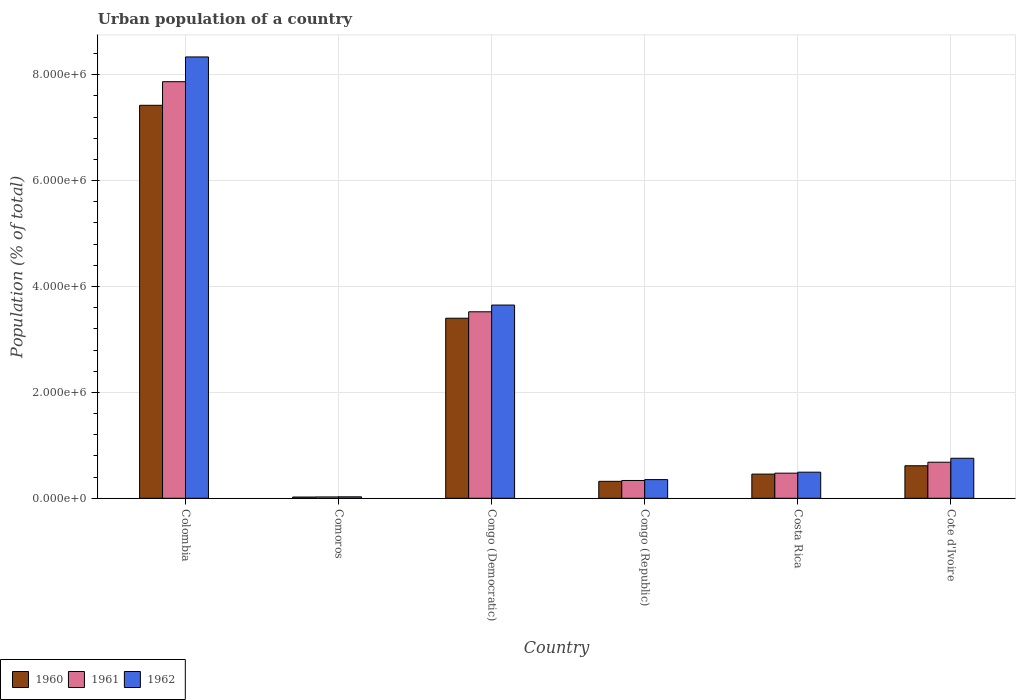How many different coloured bars are there?
Give a very brief answer. 3. Are the number of bars per tick equal to the number of legend labels?
Provide a short and direct response. Yes. Are the number of bars on each tick of the X-axis equal?
Provide a succinct answer. Yes. How many bars are there on the 4th tick from the right?
Your answer should be very brief. 3. What is the label of the 6th group of bars from the left?
Ensure brevity in your answer.  Cote d'Ivoire. What is the urban population in 1961 in Comoros?
Your answer should be compact. 2.56e+04. Across all countries, what is the maximum urban population in 1961?
Offer a terse response. 7.87e+06. Across all countries, what is the minimum urban population in 1961?
Offer a terse response. 2.56e+04. In which country was the urban population in 1960 minimum?
Give a very brief answer. Comoros. What is the total urban population in 1962 in the graph?
Provide a succinct answer. 1.36e+07. What is the difference between the urban population in 1961 in Colombia and that in Cote d'Ivoire?
Provide a succinct answer. 7.19e+06. What is the difference between the urban population in 1962 in Costa Rica and the urban population in 1960 in Congo (Republic)?
Provide a short and direct response. 1.73e+05. What is the average urban population in 1960 per country?
Offer a very short reply. 2.04e+06. What is the difference between the urban population of/in 1960 and urban population of/in 1962 in Congo (Republic)?
Make the answer very short. -3.25e+04. What is the ratio of the urban population in 1961 in Colombia to that in Congo (Republic)?
Ensure brevity in your answer.  23.41. Is the urban population in 1961 in Colombia less than that in Comoros?
Your answer should be very brief. No. Is the difference between the urban population in 1960 in Colombia and Congo (Democratic) greater than the difference between the urban population in 1962 in Colombia and Congo (Democratic)?
Ensure brevity in your answer.  No. What is the difference between the highest and the second highest urban population in 1962?
Provide a short and direct response. 7.58e+06. What is the difference between the highest and the lowest urban population in 1961?
Ensure brevity in your answer.  7.84e+06. Is the sum of the urban population in 1962 in Colombia and Comoros greater than the maximum urban population in 1960 across all countries?
Give a very brief answer. Yes. What does the 3rd bar from the left in Congo (Democratic) represents?
Your answer should be compact. 1962. Is it the case that in every country, the sum of the urban population in 1960 and urban population in 1961 is greater than the urban population in 1962?
Ensure brevity in your answer.  Yes. How many countries are there in the graph?
Provide a short and direct response. 6. Does the graph contain grids?
Give a very brief answer. Yes. What is the title of the graph?
Your response must be concise. Urban population of a country. Does "2002" appear as one of the legend labels in the graph?
Offer a terse response. No. What is the label or title of the X-axis?
Your answer should be compact. Country. What is the label or title of the Y-axis?
Your response must be concise. Population (% of total). What is the Population (% of total) in 1960 in Colombia?
Your answer should be very brief. 7.42e+06. What is the Population (% of total) in 1961 in Colombia?
Keep it short and to the point. 7.87e+06. What is the Population (% of total) of 1962 in Colombia?
Your response must be concise. 8.33e+06. What is the Population (% of total) in 1960 in Comoros?
Offer a very short reply. 2.37e+04. What is the Population (% of total) of 1961 in Comoros?
Keep it short and to the point. 2.56e+04. What is the Population (% of total) of 1962 in Comoros?
Ensure brevity in your answer.  2.77e+04. What is the Population (% of total) of 1960 in Congo (Democratic)?
Ensure brevity in your answer.  3.40e+06. What is the Population (% of total) of 1961 in Congo (Democratic)?
Give a very brief answer. 3.52e+06. What is the Population (% of total) of 1962 in Congo (Democratic)?
Your answer should be compact. 3.65e+06. What is the Population (% of total) in 1960 in Congo (Republic)?
Make the answer very short. 3.20e+05. What is the Population (% of total) in 1961 in Congo (Republic)?
Provide a succinct answer. 3.36e+05. What is the Population (% of total) in 1962 in Congo (Republic)?
Your answer should be compact. 3.53e+05. What is the Population (% of total) of 1960 in Costa Rica?
Your response must be concise. 4.57e+05. What is the Population (% of total) in 1961 in Costa Rica?
Offer a very short reply. 4.74e+05. What is the Population (% of total) of 1962 in Costa Rica?
Give a very brief answer. 4.93e+05. What is the Population (% of total) of 1960 in Cote d'Ivoire?
Provide a short and direct response. 6.14e+05. What is the Population (% of total) in 1961 in Cote d'Ivoire?
Offer a terse response. 6.81e+05. What is the Population (% of total) in 1962 in Cote d'Ivoire?
Offer a terse response. 7.56e+05. Across all countries, what is the maximum Population (% of total) in 1960?
Provide a short and direct response. 7.42e+06. Across all countries, what is the maximum Population (% of total) in 1961?
Your answer should be very brief. 7.87e+06. Across all countries, what is the maximum Population (% of total) of 1962?
Your answer should be compact. 8.33e+06. Across all countries, what is the minimum Population (% of total) in 1960?
Provide a short and direct response. 2.37e+04. Across all countries, what is the minimum Population (% of total) in 1961?
Provide a short and direct response. 2.56e+04. Across all countries, what is the minimum Population (% of total) of 1962?
Offer a terse response. 2.77e+04. What is the total Population (% of total) in 1960 in the graph?
Provide a short and direct response. 1.22e+07. What is the total Population (% of total) of 1961 in the graph?
Offer a very short reply. 1.29e+07. What is the total Population (% of total) of 1962 in the graph?
Give a very brief answer. 1.36e+07. What is the difference between the Population (% of total) of 1960 in Colombia and that in Comoros?
Your response must be concise. 7.40e+06. What is the difference between the Population (% of total) of 1961 in Colombia and that in Comoros?
Provide a short and direct response. 7.84e+06. What is the difference between the Population (% of total) in 1962 in Colombia and that in Comoros?
Ensure brevity in your answer.  8.31e+06. What is the difference between the Population (% of total) of 1960 in Colombia and that in Congo (Democratic)?
Your answer should be compact. 4.02e+06. What is the difference between the Population (% of total) of 1961 in Colombia and that in Congo (Democratic)?
Give a very brief answer. 4.35e+06. What is the difference between the Population (% of total) in 1962 in Colombia and that in Congo (Democratic)?
Give a very brief answer. 4.69e+06. What is the difference between the Population (% of total) of 1960 in Colombia and that in Congo (Republic)?
Offer a terse response. 7.10e+06. What is the difference between the Population (% of total) of 1961 in Colombia and that in Congo (Republic)?
Keep it short and to the point. 7.53e+06. What is the difference between the Population (% of total) of 1962 in Colombia and that in Congo (Republic)?
Provide a short and direct response. 7.98e+06. What is the difference between the Population (% of total) of 1960 in Colombia and that in Costa Rica?
Give a very brief answer. 6.96e+06. What is the difference between the Population (% of total) in 1961 in Colombia and that in Costa Rica?
Your answer should be compact. 7.39e+06. What is the difference between the Population (% of total) in 1962 in Colombia and that in Costa Rica?
Offer a very short reply. 7.84e+06. What is the difference between the Population (% of total) in 1960 in Colombia and that in Cote d'Ivoire?
Offer a very short reply. 6.81e+06. What is the difference between the Population (% of total) in 1961 in Colombia and that in Cote d'Ivoire?
Provide a short and direct response. 7.19e+06. What is the difference between the Population (% of total) of 1962 in Colombia and that in Cote d'Ivoire?
Your answer should be very brief. 7.58e+06. What is the difference between the Population (% of total) of 1960 in Comoros and that in Congo (Democratic)?
Your response must be concise. -3.38e+06. What is the difference between the Population (% of total) in 1961 in Comoros and that in Congo (Democratic)?
Give a very brief answer. -3.50e+06. What is the difference between the Population (% of total) in 1962 in Comoros and that in Congo (Democratic)?
Offer a very short reply. -3.62e+06. What is the difference between the Population (% of total) of 1960 in Comoros and that in Congo (Republic)?
Provide a succinct answer. -2.97e+05. What is the difference between the Population (% of total) in 1961 in Comoros and that in Congo (Republic)?
Your response must be concise. -3.10e+05. What is the difference between the Population (% of total) in 1962 in Comoros and that in Congo (Republic)?
Give a very brief answer. -3.25e+05. What is the difference between the Population (% of total) in 1960 in Comoros and that in Costa Rica?
Ensure brevity in your answer.  -4.33e+05. What is the difference between the Population (% of total) of 1961 in Comoros and that in Costa Rica?
Your answer should be compact. -4.49e+05. What is the difference between the Population (% of total) in 1962 in Comoros and that in Costa Rica?
Your answer should be compact. -4.65e+05. What is the difference between the Population (% of total) of 1960 in Comoros and that in Cote d'Ivoire?
Keep it short and to the point. -5.91e+05. What is the difference between the Population (% of total) of 1961 in Comoros and that in Cote d'Ivoire?
Your response must be concise. -6.56e+05. What is the difference between the Population (% of total) in 1962 in Comoros and that in Cote d'Ivoire?
Your response must be concise. -7.28e+05. What is the difference between the Population (% of total) in 1960 in Congo (Democratic) and that in Congo (Republic)?
Provide a succinct answer. 3.08e+06. What is the difference between the Population (% of total) in 1961 in Congo (Democratic) and that in Congo (Republic)?
Give a very brief answer. 3.19e+06. What is the difference between the Population (% of total) in 1962 in Congo (Democratic) and that in Congo (Republic)?
Offer a terse response. 3.30e+06. What is the difference between the Population (% of total) in 1960 in Congo (Democratic) and that in Costa Rica?
Offer a very short reply. 2.94e+06. What is the difference between the Population (% of total) in 1961 in Congo (Democratic) and that in Costa Rica?
Provide a short and direct response. 3.05e+06. What is the difference between the Population (% of total) in 1962 in Congo (Democratic) and that in Costa Rica?
Provide a succinct answer. 3.16e+06. What is the difference between the Population (% of total) of 1960 in Congo (Democratic) and that in Cote d'Ivoire?
Your answer should be very brief. 2.79e+06. What is the difference between the Population (% of total) of 1961 in Congo (Democratic) and that in Cote d'Ivoire?
Make the answer very short. 2.84e+06. What is the difference between the Population (% of total) of 1962 in Congo (Democratic) and that in Cote d'Ivoire?
Keep it short and to the point. 2.89e+06. What is the difference between the Population (% of total) of 1960 in Congo (Republic) and that in Costa Rica?
Ensure brevity in your answer.  -1.36e+05. What is the difference between the Population (% of total) of 1961 in Congo (Republic) and that in Costa Rica?
Keep it short and to the point. -1.38e+05. What is the difference between the Population (% of total) of 1962 in Congo (Republic) and that in Costa Rica?
Offer a very short reply. -1.40e+05. What is the difference between the Population (% of total) of 1960 in Congo (Republic) and that in Cote d'Ivoire?
Ensure brevity in your answer.  -2.94e+05. What is the difference between the Population (% of total) in 1961 in Congo (Republic) and that in Cote d'Ivoire?
Offer a very short reply. -3.45e+05. What is the difference between the Population (% of total) of 1962 in Congo (Republic) and that in Cote d'Ivoire?
Ensure brevity in your answer.  -4.03e+05. What is the difference between the Population (% of total) in 1960 in Costa Rica and that in Cote d'Ivoire?
Provide a short and direct response. -1.58e+05. What is the difference between the Population (% of total) of 1961 in Costa Rica and that in Cote d'Ivoire?
Your answer should be compact. -2.07e+05. What is the difference between the Population (% of total) of 1962 in Costa Rica and that in Cote d'Ivoire?
Provide a short and direct response. -2.63e+05. What is the difference between the Population (% of total) in 1960 in Colombia and the Population (% of total) in 1961 in Comoros?
Make the answer very short. 7.40e+06. What is the difference between the Population (% of total) in 1960 in Colombia and the Population (% of total) in 1962 in Comoros?
Offer a very short reply. 7.39e+06. What is the difference between the Population (% of total) of 1961 in Colombia and the Population (% of total) of 1962 in Comoros?
Ensure brevity in your answer.  7.84e+06. What is the difference between the Population (% of total) of 1960 in Colombia and the Population (% of total) of 1961 in Congo (Democratic)?
Give a very brief answer. 3.90e+06. What is the difference between the Population (% of total) in 1960 in Colombia and the Population (% of total) in 1962 in Congo (Democratic)?
Give a very brief answer. 3.77e+06. What is the difference between the Population (% of total) in 1961 in Colombia and the Population (% of total) in 1962 in Congo (Democratic)?
Provide a short and direct response. 4.22e+06. What is the difference between the Population (% of total) in 1960 in Colombia and the Population (% of total) in 1961 in Congo (Republic)?
Your answer should be compact. 7.09e+06. What is the difference between the Population (% of total) in 1960 in Colombia and the Population (% of total) in 1962 in Congo (Republic)?
Your answer should be compact. 7.07e+06. What is the difference between the Population (% of total) of 1961 in Colombia and the Population (% of total) of 1962 in Congo (Republic)?
Provide a short and direct response. 7.51e+06. What is the difference between the Population (% of total) of 1960 in Colombia and the Population (% of total) of 1961 in Costa Rica?
Your answer should be very brief. 6.95e+06. What is the difference between the Population (% of total) of 1960 in Colombia and the Population (% of total) of 1962 in Costa Rica?
Give a very brief answer. 6.93e+06. What is the difference between the Population (% of total) in 1961 in Colombia and the Population (% of total) in 1962 in Costa Rica?
Make the answer very short. 7.37e+06. What is the difference between the Population (% of total) of 1960 in Colombia and the Population (% of total) of 1961 in Cote d'Ivoire?
Your response must be concise. 6.74e+06. What is the difference between the Population (% of total) of 1960 in Colombia and the Population (% of total) of 1962 in Cote d'Ivoire?
Ensure brevity in your answer.  6.67e+06. What is the difference between the Population (% of total) of 1961 in Colombia and the Population (% of total) of 1962 in Cote d'Ivoire?
Your answer should be very brief. 7.11e+06. What is the difference between the Population (% of total) of 1960 in Comoros and the Population (% of total) of 1961 in Congo (Democratic)?
Ensure brevity in your answer.  -3.50e+06. What is the difference between the Population (% of total) of 1960 in Comoros and the Population (% of total) of 1962 in Congo (Democratic)?
Keep it short and to the point. -3.63e+06. What is the difference between the Population (% of total) of 1961 in Comoros and the Population (% of total) of 1962 in Congo (Democratic)?
Keep it short and to the point. -3.62e+06. What is the difference between the Population (% of total) in 1960 in Comoros and the Population (% of total) in 1961 in Congo (Republic)?
Provide a short and direct response. -3.12e+05. What is the difference between the Population (% of total) of 1960 in Comoros and the Population (% of total) of 1962 in Congo (Republic)?
Make the answer very short. -3.29e+05. What is the difference between the Population (% of total) of 1961 in Comoros and the Population (% of total) of 1962 in Congo (Republic)?
Provide a succinct answer. -3.27e+05. What is the difference between the Population (% of total) of 1960 in Comoros and the Population (% of total) of 1961 in Costa Rica?
Your answer should be compact. -4.51e+05. What is the difference between the Population (% of total) of 1960 in Comoros and the Population (% of total) of 1962 in Costa Rica?
Give a very brief answer. -4.69e+05. What is the difference between the Population (% of total) of 1961 in Comoros and the Population (% of total) of 1962 in Costa Rica?
Keep it short and to the point. -4.67e+05. What is the difference between the Population (% of total) of 1960 in Comoros and the Population (% of total) of 1961 in Cote d'Ivoire?
Offer a terse response. -6.58e+05. What is the difference between the Population (% of total) of 1960 in Comoros and the Population (% of total) of 1962 in Cote d'Ivoire?
Make the answer very short. -7.32e+05. What is the difference between the Population (% of total) in 1961 in Comoros and the Population (% of total) in 1962 in Cote d'Ivoire?
Provide a short and direct response. -7.30e+05. What is the difference between the Population (% of total) of 1960 in Congo (Democratic) and the Population (% of total) of 1961 in Congo (Republic)?
Offer a terse response. 3.06e+06. What is the difference between the Population (% of total) in 1960 in Congo (Democratic) and the Population (% of total) in 1962 in Congo (Republic)?
Your response must be concise. 3.05e+06. What is the difference between the Population (% of total) in 1961 in Congo (Democratic) and the Population (% of total) in 1962 in Congo (Republic)?
Keep it short and to the point. 3.17e+06. What is the difference between the Population (% of total) of 1960 in Congo (Democratic) and the Population (% of total) of 1961 in Costa Rica?
Keep it short and to the point. 2.93e+06. What is the difference between the Population (% of total) of 1960 in Congo (Democratic) and the Population (% of total) of 1962 in Costa Rica?
Offer a terse response. 2.91e+06. What is the difference between the Population (% of total) of 1961 in Congo (Democratic) and the Population (% of total) of 1962 in Costa Rica?
Give a very brief answer. 3.03e+06. What is the difference between the Population (% of total) of 1960 in Congo (Democratic) and the Population (% of total) of 1961 in Cote d'Ivoire?
Offer a terse response. 2.72e+06. What is the difference between the Population (% of total) of 1960 in Congo (Democratic) and the Population (% of total) of 1962 in Cote d'Ivoire?
Give a very brief answer. 2.64e+06. What is the difference between the Population (% of total) in 1961 in Congo (Democratic) and the Population (% of total) in 1962 in Cote d'Ivoire?
Offer a terse response. 2.77e+06. What is the difference between the Population (% of total) of 1960 in Congo (Republic) and the Population (% of total) of 1961 in Costa Rica?
Your answer should be very brief. -1.54e+05. What is the difference between the Population (% of total) in 1960 in Congo (Republic) and the Population (% of total) in 1962 in Costa Rica?
Ensure brevity in your answer.  -1.73e+05. What is the difference between the Population (% of total) of 1961 in Congo (Republic) and the Population (% of total) of 1962 in Costa Rica?
Your answer should be very brief. -1.57e+05. What is the difference between the Population (% of total) in 1960 in Congo (Republic) and the Population (% of total) in 1961 in Cote d'Ivoire?
Ensure brevity in your answer.  -3.61e+05. What is the difference between the Population (% of total) in 1960 in Congo (Republic) and the Population (% of total) in 1962 in Cote d'Ivoire?
Give a very brief answer. -4.36e+05. What is the difference between the Population (% of total) in 1961 in Congo (Republic) and the Population (% of total) in 1962 in Cote d'Ivoire?
Ensure brevity in your answer.  -4.20e+05. What is the difference between the Population (% of total) of 1960 in Costa Rica and the Population (% of total) of 1961 in Cote d'Ivoire?
Your answer should be very brief. -2.25e+05. What is the difference between the Population (% of total) of 1960 in Costa Rica and the Population (% of total) of 1962 in Cote d'Ivoire?
Your response must be concise. -2.99e+05. What is the difference between the Population (% of total) in 1961 in Costa Rica and the Population (% of total) in 1962 in Cote d'Ivoire?
Provide a short and direct response. -2.82e+05. What is the average Population (% of total) of 1960 per country?
Provide a short and direct response. 2.04e+06. What is the average Population (% of total) of 1961 per country?
Your response must be concise. 2.15e+06. What is the average Population (% of total) of 1962 per country?
Your response must be concise. 2.27e+06. What is the difference between the Population (% of total) of 1960 and Population (% of total) of 1961 in Colombia?
Provide a short and direct response. -4.46e+05. What is the difference between the Population (% of total) of 1960 and Population (% of total) of 1962 in Colombia?
Ensure brevity in your answer.  -9.13e+05. What is the difference between the Population (% of total) in 1961 and Population (% of total) in 1962 in Colombia?
Your response must be concise. -4.68e+05. What is the difference between the Population (% of total) in 1960 and Population (% of total) in 1961 in Comoros?
Give a very brief answer. -1917. What is the difference between the Population (% of total) in 1960 and Population (% of total) in 1962 in Comoros?
Provide a short and direct response. -3975. What is the difference between the Population (% of total) of 1961 and Population (% of total) of 1962 in Comoros?
Your response must be concise. -2058. What is the difference between the Population (% of total) in 1960 and Population (% of total) in 1961 in Congo (Democratic)?
Provide a succinct answer. -1.22e+05. What is the difference between the Population (% of total) in 1960 and Population (% of total) in 1962 in Congo (Democratic)?
Make the answer very short. -2.49e+05. What is the difference between the Population (% of total) in 1961 and Population (% of total) in 1962 in Congo (Democratic)?
Provide a succinct answer. -1.27e+05. What is the difference between the Population (% of total) in 1960 and Population (% of total) in 1961 in Congo (Republic)?
Offer a very short reply. -1.58e+04. What is the difference between the Population (% of total) of 1960 and Population (% of total) of 1962 in Congo (Republic)?
Offer a terse response. -3.25e+04. What is the difference between the Population (% of total) of 1961 and Population (% of total) of 1962 in Congo (Republic)?
Provide a succinct answer. -1.67e+04. What is the difference between the Population (% of total) of 1960 and Population (% of total) of 1961 in Costa Rica?
Keep it short and to the point. -1.78e+04. What is the difference between the Population (% of total) in 1960 and Population (% of total) in 1962 in Costa Rica?
Your answer should be compact. -3.62e+04. What is the difference between the Population (% of total) of 1961 and Population (% of total) of 1962 in Costa Rica?
Your response must be concise. -1.85e+04. What is the difference between the Population (% of total) in 1960 and Population (% of total) in 1961 in Cote d'Ivoire?
Offer a very short reply. -6.69e+04. What is the difference between the Population (% of total) of 1960 and Population (% of total) of 1962 in Cote d'Ivoire?
Your answer should be very brief. -1.42e+05. What is the difference between the Population (% of total) in 1961 and Population (% of total) in 1962 in Cote d'Ivoire?
Offer a terse response. -7.48e+04. What is the ratio of the Population (% of total) of 1960 in Colombia to that in Comoros?
Your answer should be very brief. 313.31. What is the ratio of the Population (% of total) of 1961 in Colombia to that in Comoros?
Give a very brief answer. 307.26. What is the ratio of the Population (% of total) in 1962 in Colombia to that in Comoros?
Provide a succinct answer. 301.3. What is the ratio of the Population (% of total) of 1960 in Colombia to that in Congo (Democratic)?
Offer a very short reply. 2.18. What is the ratio of the Population (% of total) of 1961 in Colombia to that in Congo (Democratic)?
Ensure brevity in your answer.  2.23. What is the ratio of the Population (% of total) of 1962 in Colombia to that in Congo (Democratic)?
Provide a succinct answer. 2.28. What is the ratio of the Population (% of total) in 1960 in Colombia to that in Congo (Republic)?
Keep it short and to the point. 23.17. What is the ratio of the Population (% of total) of 1961 in Colombia to that in Congo (Republic)?
Keep it short and to the point. 23.41. What is the ratio of the Population (% of total) in 1962 in Colombia to that in Congo (Republic)?
Make the answer very short. 23.63. What is the ratio of the Population (% of total) in 1960 in Colombia to that in Costa Rica?
Your answer should be very brief. 16.25. What is the ratio of the Population (% of total) of 1961 in Colombia to that in Costa Rica?
Provide a succinct answer. 16.58. What is the ratio of the Population (% of total) in 1962 in Colombia to that in Costa Rica?
Your answer should be compact. 16.91. What is the ratio of the Population (% of total) in 1960 in Colombia to that in Cote d'Ivoire?
Provide a succinct answer. 12.08. What is the ratio of the Population (% of total) in 1961 in Colombia to that in Cote d'Ivoire?
Offer a terse response. 11.55. What is the ratio of the Population (% of total) in 1962 in Colombia to that in Cote d'Ivoire?
Give a very brief answer. 11.03. What is the ratio of the Population (% of total) in 1960 in Comoros to that in Congo (Democratic)?
Ensure brevity in your answer.  0.01. What is the ratio of the Population (% of total) in 1961 in Comoros to that in Congo (Democratic)?
Your response must be concise. 0.01. What is the ratio of the Population (% of total) of 1962 in Comoros to that in Congo (Democratic)?
Your response must be concise. 0.01. What is the ratio of the Population (% of total) in 1960 in Comoros to that in Congo (Republic)?
Offer a terse response. 0.07. What is the ratio of the Population (% of total) in 1961 in Comoros to that in Congo (Republic)?
Make the answer very short. 0.08. What is the ratio of the Population (% of total) in 1962 in Comoros to that in Congo (Republic)?
Offer a terse response. 0.08. What is the ratio of the Population (% of total) of 1960 in Comoros to that in Costa Rica?
Provide a succinct answer. 0.05. What is the ratio of the Population (% of total) of 1961 in Comoros to that in Costa Rica?
Provide a short and direct response. 0.05. What is the ratio of the Population (% of total) of 1962 in Comoros to that in Costa Rica?
Offer a terse response. 0.06. What is the ratio of the Population (% of total) of 1960 in Comoros to that in Cote d'Ivoire?
Ensure brevity in your answer.  0.04. What is the ratio of the Population (% of total) of 1961 in Comoros to that in Cote d'Ivoire?
Keep it short and to the point. 0.04. What is the ratio of the Population (% of total) in 1962 in Comoros to that in Cote d'Ivoire?
Your answer should be compact. 0.04. What is the ratio of the Population (% of total) in 1960 in Congo (Democratic) to that in Congo (Republic)?
Ensure brevity in your answer.  10.62. What is the ratio of the Population (% of total) in 1961 in Congo (Democratic) to that in Congo (Republic)?
Provide a short and direct response. 10.48. What is the ratio of the Population (% of total) of 1962 in Congo (Democratic) to that in Congo (Republic)?
Your answer should be compact. 10.34. What is the ratio of the Population (% of total) in 1960 in Congo (Democratic) to that in Costa Rica?
Ensure brevity in your answer.  7.45. What is the ratio of the Population (% of total) in 1961 in Congo (Democratic) to that in Costa Rica?
Give a very brief answer. 7.42. What is the ratio of the Population (% of total) of 1962 in Congo (Democratic) to that in Costa Rica?
Your response must be concise. 7.4. What is the ratio of the Population (% of total) of 1960 in Congo (Democratic) to that in Cote d'Ivoire?
Provide a succinct answer. 5.54. What is the ratio of the Population (% of total) in 1961 in Congo (Democratic) to that in Cote d'Ivoire?
Offer a terse response. 5.17. What is the ratio of the Population (% of total) of 1962 in Congo (Democratic) to that in Cote d'Ivoire?
Ensure brevity in your answer.  4.83. What is the ratio of the Population (% of total) in 1960 in Congo (Republic) to that in Costa Rica?
Your answer should be compact. 0.7. What is the ratio of the Population (% of total) in 1961 in Congo (Republic) to that in Costa Rica?
Keep it short and to the point. 0.71. What is the ratio of the Population (% of total) of 1962 in Congo (Republic) to that in Costa Rica?
Your answer should be very brief. 0.72. What is the ratio of the Population (% of total) of 1960 in Congo (Republic) to that in Cote d'Ivoire?
Your answer should be compact. 0.52. What is the ratio of the Population (% of total) of 1961 in Congo (Republic) to that in Cote d'Ivoire?
Offer a terse response. 0.49. What is the ratio of the Population (% of total) of 1962 in Congo (Republic) to that in Cote d'Ivoire?
Provide a succinct answer. 0.47. What is the ratio of the Population (% of total) in 1960 in Costa Rica to that in Cote d'Ivoire?
Provide a succinct answer. 0.74. What is the ratio of the Population (% of total) of 1961 in Costa Rica to that in Cote d'Ivoire?
Provide a succinct answer. 0.7. What is the ratio of the Population (% of total) of 1962 in Costa Rica to that in Cote d'Ivoire?
Ensure brevity in your answer.  0.65. What is the difference between the highest and the second highest Population (% of total) in 1960?
Offer a terse response. 4.02e+06. What is the difference between the highest and the second highest Population (% of total) in 1961?
Your answer should be compact. 4.35e+06. What is the difference between the highest and the second highest Population (% of total) in 1962?
Your answer should be very brief. 4.69e+06. What is the difference between the highest and the lowest Population (% of total) in 1960?
Give a very brief answer. 7.40e+06. What is the difference between the highest and the lowest Population (% of total) in 1961?
Your answer should be very brief. 7.84e+06. What is the difference between the highest and the lowest Population (% of total) in 1962?
Keep it short and to the point. 8.31e+06. 